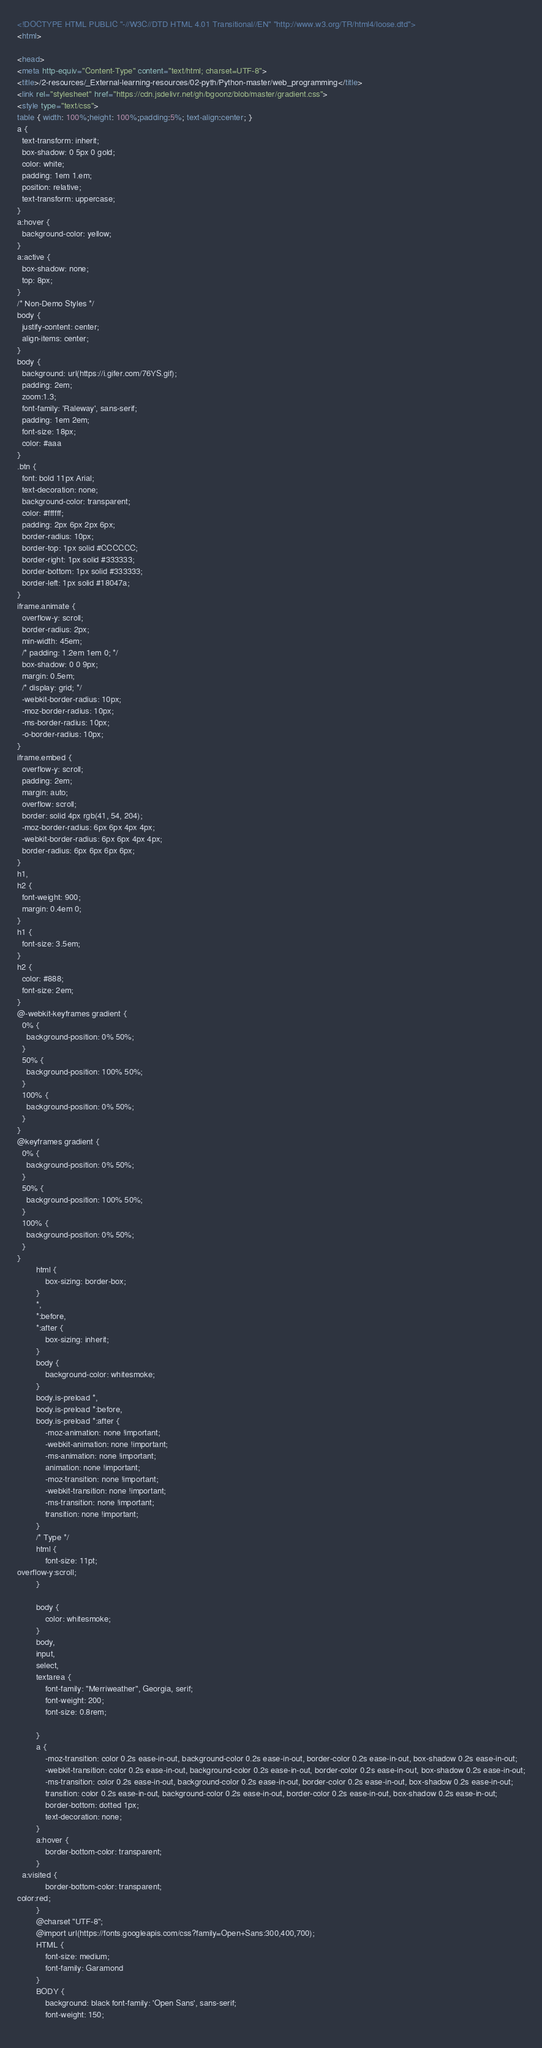Convert code to text. <code><loc_0><loc_0><loc_500><loc_500><_HTML_><!DOCTYPE HTML PUBLIC "-//W3C//DTD HTML 4.01 Transitional//EN" "http://www.w3.org/TR/html4/loose.dtd">
<html>

<head>
<meta http-equiv="Content-Type" content="text/html; charset=UTF-8">
<title>/2-resources/_External-learning-resources/02-pyth/Python-master/web_programming</title>
<link rel="stylesheet" href="https://cdn.jsdelivr.net/gh/bgoonz/blob/master/gradient.css">
<style type="text/css">
table { width: 100%;height: 100%;padding:5%; text-align:center; }
a {
  text-transform: inherit;
  box-shadow: 0 5px 0 gold;
  color: white;
  padding: 1em 1.em;
  position: relative;
  text-transform: uppercase;
}
a:hover {
  background-color: yellow;
}
a:active {
  box-shadow: none;
  top: 8px;
}
/* Non-Demo Styles */
body {
  justify-content: center;
  align-items: center;
}
body {
  background: url(https://i.gifer.com/76YS.gif);
  padding: 2em;
  zoom:1.3;
  font-family: 'Raleway', sans-serif;
  padding: 1em 2em;
  font-size: 18px;
  color: #aaa
}
.btn {
  font: bold 11px Arial;
  text-decoration: none;
  background-color: transparent;
  color: #ffffff;
  padding: 2px 6px 2px 6px;
  border-radius: 10px;
  border-top: 1px solid #CCCCCC;
  border-right: 1px solid #333333;
  border-bottom: 1px solid #333333;
  border-left: 1px solid #18047a;
}
iframe.animate {
  overflow-y: scroll;
  border-radius: 2px;
  min-width: 45em;
  /* padding: 1.2em 1em 0; */
  box-shadow: 0 0 9px;
  margin: 0.5em;
  /* display: grid; */
  -webkit-border-radius: 10px;
  -moz-border-radius: 10px;
  -ms-border-radius: 10px;
  -o-border-radius: 10px;
}
iframe.embed {
  overflow-y: scroll;
  padding: 2em;
  margin: auto;
  overflow: scroll;
  border: solid 4px rgb(41, 54, 204);
  -moz-border-radius: 6px 6px 4px 4px;
  -webkit-border-radius: 6px 6px 4px 4px;
  border-radius: 6px 6px 6px 6px;
}
h1,
h2 {
  font-weight: 900;
  margin: 0.4em 0;
}
h1 {
  font-size: 3.5em;
}
h2 {
  color: #888;
  font-size: 2em;
}
@-webkit-keyframes gradient {
  0% {
    background-position: 0% 50%;
  }
  50% {
    background-position: 100% 50%;
  }
  100% {
    background-position: 0% 50%;
  }
}
@keyframes gradient {
  0% {
    background-position: 0% 50%;
  }
  50% {
    background-position: 100% 50%;
  }
  100% {
    background-position: 0% 50%;
  }
}
        html {
            box-sizing: border-box;
        }
        *,
        *:before,
        *:after {
            box-sizing: inherit;
        }
        body {
            background-color: whitesmoke;
        }
        body.is-preload *,
        body.is-preload *:before,
        body.is-preload *:after {
            -moz-animation: none !important;
            -webkit-animation: none !important;
            -ms-animation: none !important;
            animation: none !important;
            -moz-transition: none !important;
            -webkit-transition: none !important;
            -ms-transition: none !important;
            transition: none !important;
        }
        /* Type */
        html {
            font-size: 11pt;
overflow-y:scroll;
        }
       
        body {
            color: whitesmoke;
        }
        body,
        input,
        select,
        textarea {
            font-family: "Merriweather", Georgia, serif;
            font-weight: 200;
            font-size: 0.8rem;
          
        }
        a {
            -moz-transition: color 0.2s ease-in-out, background-color 0.2s ease-in-out, border-color 0.2s ease-in-out, box-shadow 0.2s ease-in-out;
            -webkit-transition: color 0.2s ease-in-out, background-color 0.2s ease-in-out, border-color 0.2s ease-in-out, box-shadow 0.2s ease-in-out;
            -ms-transition: color 0.2s ease-in-out, background-color 0.2s ease-in-out, border-color 0.2s ease-in-out, box-shadow 0.2s ease-in-out;
            transition: color 0.2s ease-in-out, background-color 0.2s ease-in-out, border-color 0.2s ease-in-out, box-shadow 0.2s ease-in-out;
            border-bottom: dotted 1px;
            text-decoration: none;
        }
        a:hover {
            border-bottom-color: transparent;
        }
  a:visited {
            border-bottom-color: transparent;
color:red;
        }
        @charset "UTF-8";
        @import url(https://fonts.googleapis.com/css?family=Open+Sans:300,400,700);
        HTML {
            font-size: medium;
            font-family: Garamond
        }
        BODY {
            background: black font-family: 'Open Sans', sans-serif;
            font-weight: 150;
         </code> 